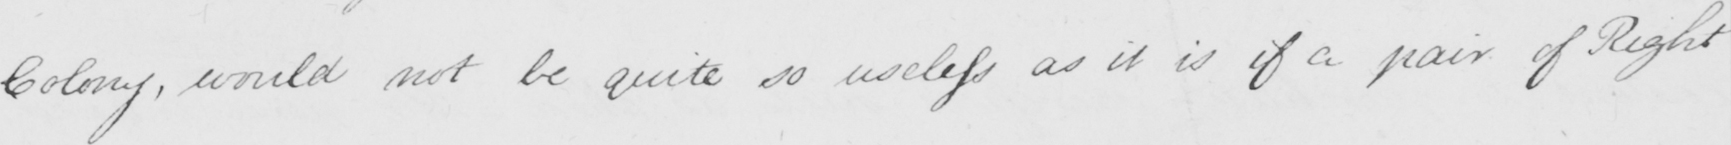Can you tell me what this handwritten text says? Colony , would not be quite so useless as it is if a pair of Right 